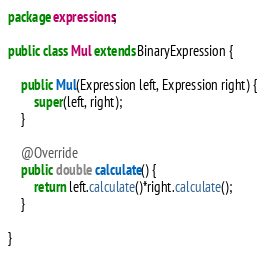Convert code to text. <code><loc_0><loc_0><loc_500><loc_500><_Java_>package expressions;

public class Mul extends BinaryExpression {

	public Mul(Expression left, Expression right) {
		super(left, right);
	}

	@Override
	public double calculate() {
		return left.calculate()*right.calculate();
	}

}
</code> 